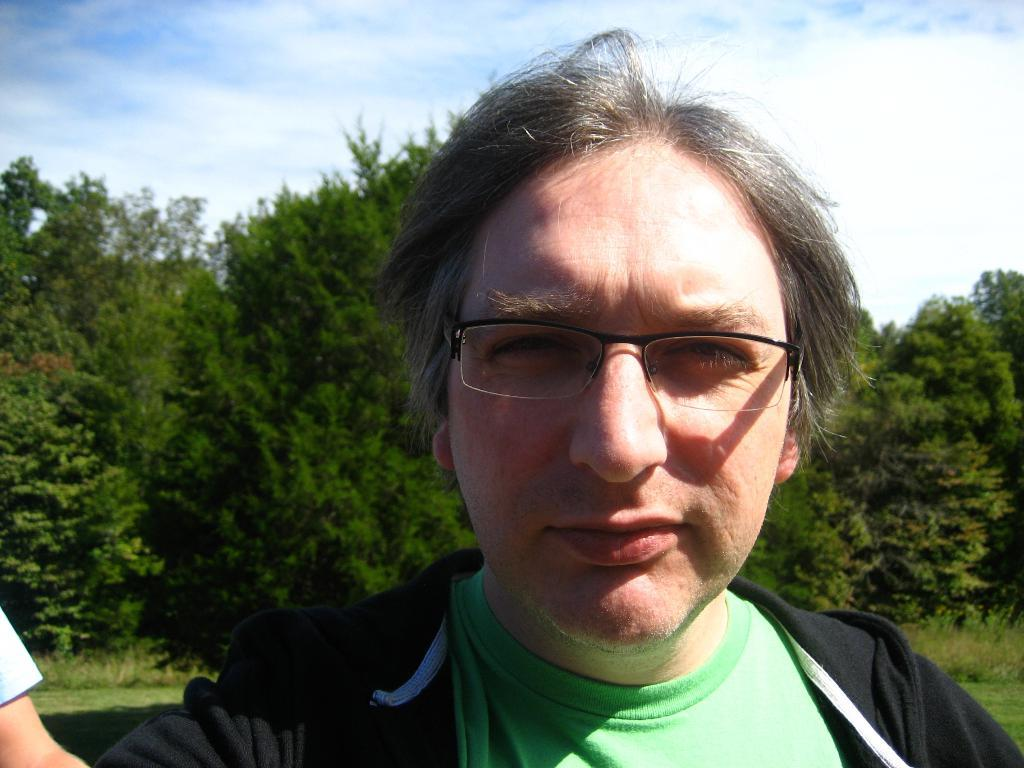Who is present in the image? There is a man in the image. What can be seen on the man's face? The man is wearing spectacles. What color jacket is the man wearing? The man is wearing a black color jacket. What type of natural environment is visible in the image? There is grass, trees, and the sky visible in the image. What is the condition of the sky in the image? The sky is visible with clouds in the image. What type of steel vest is the man wearing in the image? There is no steel vest present in the image; the man is wearing a black color jacket. How many man-made structures can be seen in the image? The provided facts do not mention any man-made structures in the image. 